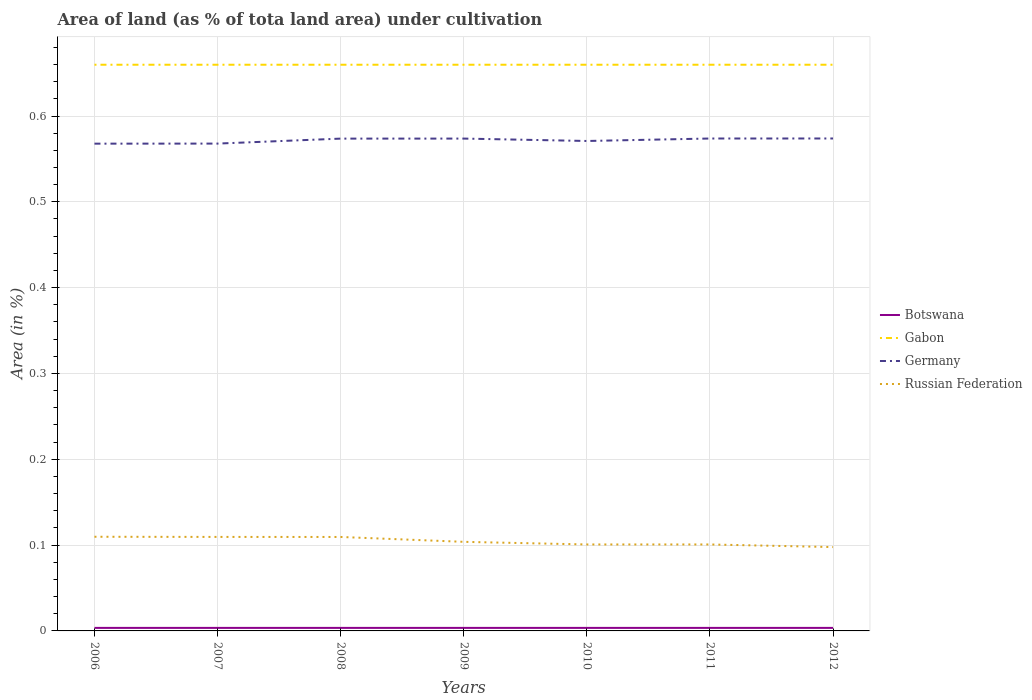How many different coloured lines are there?
Make the answer very short. 4. Does the line corresponding to Botswana intersect with the line corresponding to Gabon?
Offer a very short reply. No. Across all years, what is the maximum percentage of land under cultivation in Gabon?
Offer a terse response. 0.66. In which year was the percentage of land under cultivation in Gabon maximum?
Your answer should be very brief. 2006. What is the total percentage of land under cultivation in Germany in the graph?
Provide a short and direct response. -0.01. What is the difference between the highest and the second highest percentage of land under cultivation in Russian Federation?
Offer a very short reply. 0.01. What is the difference between the highest and the lowest percentage of land under cultivation in Russian Federation?
Ensure brevity in your answer.  3. Is the percentage of land under cultivation in Russian Federation strictly greater than the percentage of land under cultivation in Gabon over the years?
Your response must be concise. Yes. How many lines are there?
Your answer should be very brief. 4. How many years are there in the graph?
Ensure brevity in your answer.  7. Are the values on the major ticks of Y-axis written in scientific E-notation?
Your response must be concise. No. Does the graph contain any zero values?
Your response must be concise. No. Where does the legend appear in the graph?
Your answer should be compact. Center right. How are the legend labels stacked?
Your answer should be very brief. Vertical. What is the title of the graph?
Make the answer very short. Area of land (as % of tota land area) under cultivation. What is the label or title of the X-axis?
Your answer should be very brief. Years. What is the label or title of the Y-axis?
Your answer should be compact. Area (in %). What is the Area (in %) in Botswana in 2006?
Give a very brief answer. 0. What is the Area (in %) of Gabon in 2006?
Your response must be concise. 0.66. What is the Area (in %) in Germany in 2006?
Your response must be concise. 0.57. What is the Area (in %) of Russian Federation in 2006?
Your response must be concise. 0.11. What is the Area (in %) of Botswana in 2007?
Your response must be concise. 0. What is the Area (in %) in Gabon in 2007?
Your response must be concise. 0.66. What is the Area (in %) in Germany in 2007?
Keep it short and to the point. 0.57. What is the Area (in %) in Russian Federation in 2007?
Keep it short and to the point. 0.11. What is the Area (in %) in Botswana in 2008?
Provide a succinct answer. 0. What is the Area (in %) in Gabon in 2008?
Provide a succinct answer. 0.66. What is the Area (in %) in Germany in 2008?
Ensure brevity in your answer.  0.57. What is the Area (in %) of Russian Federation in 2008?
Your answer should be compact. 0.11. What is the Area (in %) in Botswana in 2009?
Offer a very short reply. 0. What is the Area (in %) of Gabon in 2009?
Your answer should be compact. 0.66. What is the Area (in %) in Germany in 2009?
Make the answer very short. 0.57. What is the Area (in %) of Russian Federation in 2009?
Your answer should be very brief. 0.1. What is the Area (in %) in Botswana in 2010?
Your response must be concise. 0. What is the Area (in %) of Gabon in 2010?
Make the answer very short. 0.66. What is the Area (in %) of Germany in 2010?
Your answer should be compact. 0.57. What is the Area (in %) of Russian Federation in 2010?
Offer a terse response. 0.1. What is the Area (in %) in Botswana in 2011?
Your answer should be very brief. 0. What is the Area (in %) in Gabon in 2011?
Keep it short and to the point. 0.66. What is the Area (in %) in Germany in 2011?
Ensure brevity in your answer.  0.57. What is the Area (in %) in Russian Federation in 2011?
Your response must be concise. 0.1. What is the Area (in %) in Botswana in 2012?
Your answer should be compact. 0. What is the Area (in %) of Gabon in 2012?
Provide a succinct answer. 0.66. What is the Area (in %) of Germany in 2012?
Provide a short and direct response. 0.57. What is the Area (in %) in Russian Federation in 2012?
Make the answer very short. 0.1. Across all years, what is the maximum Area (in %) in Botswana?
Provide a succinct answer. 0. Across all years, what is the maximum Area (in %) in Gabon?
Keep it short and to the point. 0.66. Across all years, what is the maximum Area (in %) of Germany?
Ensure brevity in your answer.  0.57. Across all years, what is the maximum Area (in %) in Russian Federation?
Ensure brevity in your answer.  0.11. Across all years, what is the minimum Area (in %) in Botswana?
Make the answer very short. 0. Across all years, what is the minimum Area (in %) of Gabon?
Offer a very short reply. 0.66. Across all years, what is the minimum Area (in %) of Germany?
Your response must be concise. 0.57. Across all years, what is the minimum Area (in %) in Russian Federation?
Your answer should be compact. 0.1. What is the total Area (in %) in Botswana in the graph?
Offer a very short reply. 0.02. What is the total Area (in %) of Gabon in the graph?
Provide a succinct answer. 4.62. What is the total Area (in %) in Germany in the graph?
Provide a short and direct response. 4. What is the total Area (in %) in Russian Federation in the graph?
Give a very brief answer. 0.73. What is the difference between the Area (in %) in Botswana in 2006 and that in 2007?
Keep it short and to the point. 0. What is the difference between the Area (in %) in Germany in 2006 and that in 2007?
Make the answer very short. -0. What is the difference between the Area (in %) in Botswana in 2006 and that in 2008?
Your answer should be compact. 0. What is the difference between the Area (in %) of Germany in 2006 and that in 2008?
Give a very brief answer. -0.01. What is the difference between the Area (in %) in Botswana in 2006 and that in 2009?
Ensure brevity in your answer.  0. What is the difference between the Area (in %) of Germany in 2006 and that in 2009?
Ensure brevity in your answer.  -0.01. What is the difference between the Area (in %) of Russian Federation in 2006 and that in 2009?
Provide a succinct answer. 0.01. What is the difference between the Area (in %) of Germany in 2006 and that in 2010?
Offer a terse response. -0. What is the difference between the Area (in %) in Russian Federation in 2006 and that in 2010?
Provide a succinct answer. 0.01. What is the difference between the Area (in %) of Germany in 2006 and that in 2011?
Your answer should be very brief. -0.01. What is the difference between the Area (in %) of Russian Federation in 2006 and that in 2011?
Give a very brief answer. 0.01. What is the difference between the Area (in %) of Germany in 2006 and that in 2012?
Provide a succinct answer. -0.01. What is the difference between the Area (in %) of Russian Federation in 2006 and that in 2012?
Give a very brief answer. 0.01. What is the difference between the Area (in %) in Germany in 2007 and that in 2008?
Keep it short and to the point. -0.01. What is the difference between the Area (in %) in Russian Federation in 2007 and that in 2008?
Your answer should be compact. 0. What is the difference between the Area (in %) in Botswana in 2007 and that in 2009?
Make the answer very short. 0. What is the difference between the Area (in %) in Gabon in 2007 and that in 2009?
Give a very brief answer. 0. What is the difference between the Area (in %) in Germany in 2007 and that in 2009?
Your answer should be very brief. -0.01. What is the difference between the Area (in %) of Russian Federation in 2007 and that in 2009?
Provide a short and direct response. 0.01. What is the difference between the Area (in %) of Germany in 2007 and that in 2010?
Your answer should be compact. -0. What is the difference between the Area (in %) of Russian Federation in 2007 and that in 2010?
Offer a terse response. 0.01. What is the difference between the Area (in %) of Germany in 2007 and that in 2011?
Keep it short and to the point. -0.01. What is the difference between the Area (in %) in Russian Federation in 2007 and that in 2011?
Make the answer very short. 0.01. What is the difference between the Area (in %) in Botswana in 2007 and that in 2012?
Ensure brevity in your answer.  0. What is the difference between the Area (in %) of Gabon in 2007 and that in 2012?
Provide a short and direct response. 0. What is the difference between the Area (in %) in Germany in 2007 and that in 2012?
Offer a very short reply. -0.01. What is the difference between the Area (in %) of Russian Federation in 2007 and that in 2012?
Offer a very short reply. 0.01. What is the difference between the Area (in %) of Botswana in 2008 and that in 2009?
Offer a very short reply. 0. What is the difference between the Area (in %) of Russian Federation in 2008 and that in 2009?
Your answer should be compact. 0.01. What is the difference between the Area (in %) in Gabon in 2008 and that in 2010?
Keep it short and to the point. 0. What is the difference between the Area (in %) of Germany in 2008 and that in 2010?
Offer a terse response. 0. What is the difference between the Area (in %) of Russian Federation in 2008 and that in 2010?
Provide a short and direct response. 0.01. What is the difference between the Area (in %) in Gabon in 2008 and that in 2011?
Your answer should be very brief. 0. What is the difference between the Area (in %) in Germany in 2008 and that in 2011?
Your answer should be compact. -0. What is the difference between the Area (in %) in Russian Federation in 2008 and that in 2011?
Offer a terse response. 0.01. What is the difference between the Area (in %) in Gabon in 2008 and that in 2012?
Give a very brief answer. 0. What is the difference between the Area (in %) of Germany in 2008 and that in 2012?
Your answer should be compact. -0. What is the difference between the Area (in %) of Russian Federation in 2008 and that in 2012?
Provide a succinct answer. 0.01. What is the difference between the Area (in %) of Botswana in 2009 and that in 2010?
Offer a terse response. 0. What is the difference between the Area (in %) of Germany in 2009 and that in 2010?
Keep it short and to the point. 0. What is the difference between the Area (in %) in Russian Federation in 2009 and that in 2010?
Provide a succinct answer. 0. What is the difference between the Area (in %) in Botswana in 2009 and that in 2011?
Ensure brevity in your answer.  0. What is the difference between the Area (in %) of Gabon in 2009 and that in 2011?
Ensure brevity in your answer.  0. What is the difference between the Area (in %) in Germany in 2009 and that in 2011?
Keep it short and to the point. -0. What is the difference between the Area (in %) of Russian Federation in 2009 and that in 2011?
Provide a short and direct response. 0. What is the difference between the Area (in %) in Botswana in 2009 and that in 2012?
Provide a succinct answer. 0. What is the difference between the Area (in %) of Gabon in 2009 and that in 2012?
Give a very brief answer. 0. What is the difference between the Area (in %) in Germany in 2009 and that in 2012?
Your answer should be very brief. -0. What is the difference between the Area (in %) of Russian Federation in 2009 and that in 2012?
Provide a succinct answer. 0.01. What is the difference between the Area (in %) in Gabon in 2010 and that in 2011?
Your answer should be compact. 0. What is the difference between the Area (in %) in Germany in 2010 and that in 2011?
Your answer should be compact. -0. What is the difference between the Area (in %) in Russian Federation in 2010 and that in 2011?
Ensure brevity in your answer.  0. What is the difference between the Area (in %) of Botswana in 2010 and that in 2012?
Provide a succinct answer. 0. What is the difference between the Area (in %) in Gabon in 2010 and that in 2012?
Keep it short and to the point. 0. What is the difference between the Area (in %) of Germany in 2010 and that in 2012?
Your response must be concise. -0. What is the difference between the Area (in %) of Russian Federation in 2010 and that in 2012?
Provide a short and direct response. 0. What is the difference between the Area (in %) in Russian Federation in 2011 and that in 2012?
Make the answer very short. 0. What is the difference between the Area (in %) of Botswana in 2006 and the Area (in %) of Gabon in 2007?
Your response must be concise. -0.66. What is the difference between the Area (in %) of Botswana in 2006 and the Area (in %) of Germany in 2007?
Give a very brief answer. -0.56. What is the difference between the Area (in %) of Botswana in 2006 and the Area (in %) of Russian Federation in 2007?
Keep it short and to the point. -0.11. What is the difference between the Area (in %) in Gabon in 2006 and the Area (in %) in Germany in 2007?
Ensure brevity in your answer.  0.09. What is the difference between the Area (in %) in Gabon in 2006 and the Area (in %) in Russian Federation in 2007?
Give a very brief answer. 0.55. What is the difference between the Area (in %) of Germany in 2006 and the Area (in %) of Russian Federation in 2007?
Give a very brief answer. 0.46. What is the difference between the Area (in %) of Botswana in 2006 and the Area (in %) of Gabon in 2008?
Your answer should be very brief. -0.66. What is the difference between the Area (in %) of Botswana in 2006 and the Area (in %) of Germany in 2008?
Provide a short and direct response. -0.57. What is the difference between the Area (in %) of Botswana in 2006 and the Area (in %) of Russian Federation in 2008?
Offer a very short reply. -0.11. What is the difference between the Area (in %) in Gabon in 2006 and the Area (in %) in Germany in 2008?
Offer a very short reply. 0.09. What is the difference between the Area (in %) of Gabon in 2006 and the Area (in %) of Russian Federation in 2008?
Offer a terse response. 0.55. What is the difference between the Area (in %) in Germany in 2006 and the Area (in %) in Russian Federation in 2008?
Ensure brevity in your answer.  0.46. What is the difference between the Area (in %) of Botswana in 2006 and the Area (in %) of Gabon in 2009?
Your answer should be compact. -0.66. What is the difference between the Area (in %) in Botswana in 2006 and the Area (in %) in Germany in 2009?
Ensure brevity in your answer.  -0.57. What is the difference between the Area (in %) of Botswana in 2006 and the Area (in %) of Russian Federation in 2009?
Provide a short and direct response. -0.1. What is the difference between the Area (in %) in Gabon in 2006 and the Area (in %) in Germany in 2009?
Your answer should be compact. 0.09. What is the difference between the Area (in %) in Gabon in 2006 and the Area (in %) in Russian Federation in 2009?
Your answer should be compact. 0.56. What is the difference between the Area (in %) of Germany in 2006 and the Area (in %) of Russian Federation in 2009?
Give a very brief answer. 0.46. What is the difference between the Area (in %) of Botswana in 2006 and the Area (in %) of Gabon in 2010?
Your answer should be very brief. -0.66. What is the difference between the Area (in %) of Botswana in 2006 and the Area (in %) of Germany in 2010?
Provide a succinct answer. -0.57. What is the difference between the Area (in %) in Botswana in 2006 and the Area (in %) in Russian Federation in 2010?
Your answer should be compact. -0.1. What is the difference between the Area (in %) of Gabon in 2006 and the Area (in %) of Germany in 2010?
Offer a very short reply. 0.09. What is the difference between the Area (in %) of Gabon in 2006 and the Area (in %) of Russian Federation in 2010?
Your answer should be compact. 0.56. What is the difference between the Area (in %) of Germany in 2006 and the Area (in %) of Russian Federation in 2010?
Keep it short and to the point. 0.47. What is the difference between the Area (in %) of Botswana in 2006 and the Area (in %) of Gabon in 2011?
Your answer should be very brief. -0.66. What is the difference between the Area (in %) in Botswana in 2006 and the Area (in %) in Germany in 2011?
Ensure brevity in your answer.  -0.57. What is the difference between the Area (in %) in Botswana in 2006 and the Area (in %) in Russian Federation in 2011?
Provide a short and direct response. -0.1. What is the difference between the Area (in %) of Gabon in 2006 and the Area (in %) of Germany in 2011?
Provide a succinct answer. 0.09. What is the difference between the Area (in %) in Gabon in 2006 and the Area (in %) in Russian Federation in 2011?
Ensure brevity in your answer.  0.56. What is the difference between the Area (in %) of Germany in 2006 and the Area (in %) of Russian Federation in 2011?
Your answer should be very brief. 0.47. What is the difference between the Area (in %) in Botswana in 2006 and the Area (in %) in Gabon in 2012?
Your response must be concise. -0.66. What is the difference between the Area (in %) of Botswana in 2006 and the Area (in %) of Germany in 2012?
Your response must be concise. -0.57. What is the difference between the Area (in %) in Botswana in 2006 and the Area (in %) in Russian Federation in 2012?
Your response must be concise. -0.09. What is the difference between the Area (in %) in Gabon in 2006 and the Area (in %) in Germany in 2012?
Provide a short and direct response. 0.09. What is the difference between the Area (in %) in Gabon in 2006 and the Area (in %) in Russian Federation in 2012?
Your response must be concise. 0.56. What is the difference between the Area (in %) of Germany in 2006 and the Area (in %) of Russian Federation in 2012?
Offer a terse response. 0.47. What is the difference between the Area (in %) of Botswana in 2007 and the Area (in %) of Gabon in 2008?
Your response must be concise. -0.66. What is the difference between the Area (in %) of Botswana in 2007 and the Area (in %) of Germany in 2008?
Your answer should be compact. -0.57. What is the difference between the Area (in %) in Botswana in 2007 and the Area (in %) in Russian Federation in 2008?
Give a very brief answer. -0.11. What is the difference between the Area (in %) in Gabon in 2007 and the Area (in %) in Germany in 2008?
Make the answer very short. 0.09. What is the difference between the Area (in %) in Gabon in 2007 and the Area (in %) in Russian Federation in 2008?
Your response must be concise. 0.55. What is the difference between the Area (in %) in Germany in 2007 and the Area (in %) in Russian Federation in 2008?
Provide a short and direct response. 0.46. What is the difference between the Area (in %) of Botswana in 2007 and the Area (in %) of Gabon in 2009?
Provide a short and direct response. -0.66. What is the difference between the Area (in %) in Botswana in 2007 and the Area (in %) in Germany in 2009?
Ensure brevity in your answer.  -0.57. What is the difference between the Area (in %) in Botswana in 2007 and the Area (in %) in Russian Federation in 2009?
Offer a very short reply. -0.1. What is the difference between the Area (in %) in Gabon in 2007 and the Area (in %) in Germany in 2009?
Offer a very short reply. 0.09. What is the difference between the Area (in %) in Gabon in 2007 and the Area (in %) in Russian Federation in 2009?
Provide a succinct answer. 0.56. What is the difference between the Area (in %) of Germany in 2007 and the Area (in %) of Russian Federation in 2009?
Give a very brief answer. 0.46. What is the difference between the Area (in %) of Botswana in 2007 and the Area (in %) of Gabon in 2010?
Offer a terse response. -0.66. What is the difference between the Area (in %) in Botswana in 2007 and the Area (in %) in Germany in 2010?
Ensure brevity in your answer.  -0.57. What is the difference between the Area (in %) in Botswana in 2007 and the Area (in %) in Russian Federation in 2010?
Offer a very short reply. -0.1. What is the difference between the Area (in %) of Gabon in 2007 and the Area (in %) of Germany in 2010?
Give a very brief answer. 0.09. What is the difference between the Area (in %) in Gabon in 2007 and the Area (in %) in Russian Federation in 2010?
Offer a very short reply. 0.56. What is the difference between the Area (in %) in Germany in 2007 and the Area (in %) in Russian Federation in 2010?
Make the answer very short. 0.47. What is the difference between the Area (in %) in Botswana in 2007 and the Area (in %) in Gabon in 2011?
Ensure brevity in your answer.  -0.66. What is the difference between the Area (in %) of Botswana in 2007 and the Area (in %) of Germany in 2011?
Keep it short and to the point. -0.57. What is the difference between the Area (in %) of Botswana in 2007 and the Area (in %) of Russian Federation in 2011?
Your answer should be compact. -0.1. What is the difference between the Area (in %) in Gabon in 2007 and the Area (in %) in Germany in 2011?
Your answer should be very brief. 0.09. What is the difference between the Area (in %) of Gabon in 2007 and the Area (in %) of Russian Federation in 2011?
Offer a very short reply. 0.56. What is the difference between the Area (in %) in Germany in 2007 and the Area (in %) in Russian Federation in 2011?
Your answer should be compact. 0.47. What is the difference between the Area (in %) of Botswana in 2007 and the Area (in %) of Gabon in 2012?
Your answer should be compact. -0.66. What is the difference between the Area (in %) in Botswana in 2007 and the Area (in %) in Germany in 2012?
Keep it short and to the point. -0.57. What is the difference between the Area (in %) in Botswana in 2007 and the Area (in %) in Russian Federation in 2012?
Your answer should be very brief. -0.09. What is the difference between the Area (in %) of Gabon in 2007 and the Area (in %) of Germany in 2012?
Provide a succinct answer. 0.09. What is the difference between the Area (in %) of Gabon in 2007 and the Area (in %) of Russian Federation in 2012?
Offer a very short reply. 0.56. What is the difference between the Area (in %) in Germany in 2007 and the Area (in %) in Russian Federation in 2012?
Ensure brevity in your answer.  0.47. What is the difference between the Area (in %) of Botswana in 2008 and the Area (in %) of Gabon in 2009?
Make the answer very short. -0.66. What is the difference between the Area (in %) of Botswana in 2008 and the Area (in %) of Germany in 2009?
Keep it short and to the point. -0.57. What is the difference between the Area (in %) in Botswana in 2008 and the Area (in %) in Russian Federation in 2009?
Your answer should be compact. -0.1. What is the difference between the Area (in %) of Gabon in 2008 and the Area (in %) of Germany in 2009?
Make the answer very short. 0.09. What is the difference between the Area (in %) in Gabon in 2008 and the Area (in %) in Russian Federation in 2009?
Provide a succinct answer. 0.56. What is the difference between the Area (in %) of Germany in 2008 and the Area (in %) of Russian Federation in 2009?
Ensure brevity in your answer.  0.47. What is the difference between the Area (in %) of Botswana in 2008 and the Area (in %) of Gabon in 2010?
Your answer should be compact. -0.66. What is the difference between the Area (in %) of Botswana in 2008 and the Area (in %) of Germany in 2010?
Provide a succinct answer. -0.57. What is the difference between the Area (in %) of Botswana in 2008 and the Area (in %) of Russian Federation in 2010?
Give a very brief answer. -0.1. What is the difference between the Area (in %) in Gabon in 2008 and the Area (in %) in Germany in 2010?
Offer a terse response. 0.09. What is the difference between the Area (in %) in Gabon in 2008 and the Area (in %) in Russian Federation in 2010?
Give a very brief answer. 0.56. What is the difference between the Area (in %) of Germany in 2008 and the Area (in %) of Russian Federation in 2010?
Keep it short and to the point. 0.47. What is the difference between the Area (in %) of Botswana in 2008 and the Area (in %) of Gabon in 2011?
Keep it short and to the point. -0.66. What is the difference between the Area (in %) of Botswana in 2008 and the Area (in %) of Germany in 2011?
Give a very brief answer. -0.57. What is the difference between the Area (in %) of Botswana in 2008 and the Area (in %) of Russian Federation in 2011?
Keep it short and to the point. -0.1. What is the difference between the Area (in %) in Gabon in 2008 and the Area (in %) in Germany in 2011?
Provide a short and direct response. 0.09. What is the difference between the Area (in %) in Gabon in 2008 and the Area (in %) in Russian Federation in 2011?
Provide a short and direct response. 0.56. What is the difference between the Area (in %) in Germany in 2008 and the Area (in %) in Russian Federation in 2011?
Make the answer very short. 0.47. What is the difference between the Area (in %) in Botswana in 2008 and the Area (in %) in Gabon in 2012?
Your response must be concise. -0.66. What is the difference between the Area (in %) in Botswana in 2008 and the Area (in %) in Germany in 2012?
Ensure brevity in your answer.  -0.57. What is the difference between the Area (in %) of Botswana in 2008 and the Area (in %) of Russian Federation in 2012?
Offer a terse response. -0.09. What is the difference between the Area (in %) of Gabon in 2008 and the Area (in %) of Germany in 2012?
Your answer should be very brief. 0.09. What is the difference between the Area (in %) of Gabon in 2008 and the Area (in %) of Russian Federation in 2012?
Give a very brief answer. 0.56. What is the difference between the Area (in %) of Germany in 2008 and the Area (in %) of Russian Federation in 2012?
Offer a very short reply. 0.48. What is the difference between the Area (in %) in Botswana in 2009 and the Area (in %) in Gabon in 2010?
Your answer should be compact. -0.66. What is the difference between the Area (in %) in Botswana in 2009 and the Area (in %) in Germany in 2010?
Keep it short and to the point. -0.57. What is the difference between the Area (in %) in Botswana in 2009 and the Area (in %) in Russian Federation in 2010?
Offer a terse response. -0.1. What is the difference between the Area (in %) of Gabon in 2009 and the Area (in %) of Germany in 2010?
Provide a succinct answer. 0.09. What is the difference between the Area (in %) of Gabon in 2009 and the Area (in %) of Russian Federation in 2010?
Your response must be concise. 0.56. What is the difference between the Area (in %) in Germany in 2009 and the Area (in %) in Russian Federation in 2010?
Make the answer very short. 0.47. What is the difference between the Area (in %) of Botswana in 2009 and the Area (in %) of Gabon in 2011?
Ensure brevity in your answer.  -0.66. What is the difference between the Area (in %) of Botswana in 2009 and the Area (in %) of Germany in 2011?
Keep it short and to the point. -0.57. What is the difference between the Area (in %) of Botswana in 2009 and the Area (in %) of Russian Federation in 2011?
Provide a short and direct response. -0.1. What is the difference between the Area (in %) in Gabon in 2009 and the Area (in %) in Germany in 2011?
Your response must be concise. 0.09. What is the difference between the Area (in %) in Gabon in 2009 and the Area (in %) in Russian Federation in 2011?
Make the answer very short. 0.56. What is the difference between the Area (in %) in Germany in 2009 and the Area (in %) in Russian Federation in 2011?
Your answer should be very brief. 0.47. What is the difference between the Area (in %) in Botswana in 2009 and the Area (in %) in Gabon in 2012?
Ensure brevity in your answer.  -0.66. What is the difference between the Area (in %) in Botswana in 2009 and the Area (in %) in Germany in 2012?
Offer a very short reply. -0.57. What is the difference between the Area (in %) in Botswana in 2009 and the Area (in %) in Russian Federation in 2012?
Make the answer very short. -0.09. What is the difference between the Area (in %) of Gabon in 2009 and the Area (in %) of Germany in 2012?
Give a very brief answer. 0.09. What is the difference between the Area (in %) in Gabon in 2009 and the Area (in %) in Russian Federation in 2012?
Ensure brevity in your answer.  0.56. What is the difference between the Area (in %) in Germany in 2009 and the Area (in %) in Russian Federation in 2012?
Provide a short and direct response. 0.48. What is the difference between the Area (in %) of Botswana in 2010 and the Area (in %) of Gabon in 2011?
Make the answer very short. -0.66. What is the difference between the Area (in %) in Botswana in 2010 and the Area (in %) in Germany in 2011?
Provide a succinct answer. -0.57. What is the difference between the Area (in %) in Botswana in 2010 and the Area (in %) in Russian Federation in 2011?
Ensure brevity in your answer.  -0.1. What is the difference between the Area (in %) in Gabon in 2010 and the Area (in %) in Germany in 2011?
Your answer should be very brief. 0.09. What is the difference between the Area (in %) in Gabon in 2010 and the Area (in %) in Russian Federation in 2011?
Give a very brief answer. 0.56. What is the difference between the Area (in %) in Germany in 2010 and the Area (in %) in Russian Federation in 2011?
Give a very brief answer. 0.47. What is the difference between the Area (in %) in Botswana in 2010 and the Area (in %) in Gabon in 2012?
Keep it short and to the point. -0.66. What is the difference between the Area (in %) of Botswana in 2010 and the Area (in %) of Germany in 2012?
Your response must be concise. -0.57. What is the difference between the Area (in %) of Botswana in 2010 and the Area (in %) of Russian Federation in 2012?
Make the answer very short. -0.09. What is the difference between the Area (in %) of Gabon in 2010 and the Area (in %) of Germany in 2012?
Give a very brief answer. 0.09. What is the difference between the Area (in %) of Gabon in 2010 and the Area (in %) of Russian Federation in 2012?
Keep it short and to the point. 0.56. What is the difference between the Area (in %) in Germany in 2010 and the Area (in %) in Russian Federation in 2012?
Keep it short and to the point. 0.47. What is the difference between the Area (in %) of Botswana in 2011 and the Area (in %) of Gabon in 2012?
Your response must be concise. -0.66. What is the difference between the Area (in %) in Botswana in 2011 and the Area (in %) in Germany in 2012?
Ensure brevity in your answer.  -0.57. What is the difference between the Area (in %) in Botswana in 2011 and the Area (in %) in Russian Federation in 2012?
Offer a terse response. -0.09. What is the difference between the Area (in %) of Gabon in 2011 and the Area (in %) of Germany in 2012?
Offer a very short reply. 0.09. What is the difference between the Area (in %) in Gabon in 2011 and the Area (in %) in Russian Federation in 2012?
Offer a terse response. 0.56. What is the difference between the Area (in %) of Germany in 2011 and the Area (in %) of Russian Federation in 2012?
Your response must be concise. 0.48. What is the average Area (in %) of Botswana per year?
Provide a short and direct response. 0. What is the average Area (in %) in Gabon per year?
Keep it short and to the point. 0.66. What is the average Area (in %) of Germany per year?
Offer a terse response. 0.57. What is the average Area (in %) of Russian Federation per year?
Offer a very short reply. 0.1. In the year 2006, what is the difference between the Area (in %) in Botswana and Area (in %) in Gabon?
Offer a very short reply. -0.66. In the year 2006, what is the difference between the Area (in %) in Botswana and Area (in %) in Germany?
Ensure brevity in your answer.  -0.56. In the year 2006, what is the difference between the Area (in %) of Botswana and Area (in %) of Russian Federation?
Offer a terse response. -0.11. In the year 2006, what is the difference between the Area (in %) in Gabon and Area (in %) in Germany?
Your answer should be compact. 0.09. In the year 2006, what is the difference between the Area (in %) in Gabon and Area (in %) in Russian Federation?
Make the answer very short. 0.55. In the year 2006, what is the difference between the Area (in %) of Germany and Area (in %) of Russian Federation?
Your answer should be very brief. 0.46. In the year 2007, what is the difference between the Area (in %) in Botswana and Area (in %) in Gabon?
Offer a terse response. -0.66. In the year 2007, what is the difference between the Area (in %) in Botswana and Area (in %) in Germany?
Keep it short and to the point. -0.56. In the year 2007, what is the difference between the Area (in %) in Botswana and Area (in %) in Russian Federation?
Offer a very short reply. -0.11. In the year 2007, what is the difference between the Area (in %) in Gabon and Area (in %) in Germany?
Your answer should be compact. 0.09. In the year 2007, what is the difference between the Area (in %) of Gabon and Area (in %) of Russian Federation?
Give a very brief answer. 0.55. In the year 2007, what is the difference between the Area (in %) in Germany and Area (in %) in Russian Federation?
Your answer should be compact. 0.46. In the year 2008, what is the difference between the Area (in %) in Botswana and Area (in %) in Gabon?
Make the answer very short. -0.66. In the year 2008, what is the difference between the Area (in %) in Botswana and Area (in %) in Germany?
Ensure brevity in your answer.  -0.57. In the year 2008, what is the difference between the Area (in %) in Botswana and Area (in %) in Russian Federation?
Provide a short and direct response. -0.11. In the year 2008, what is the difference between the Area (in %) of Gabon and Area (in %) of Germany?
Offer a very short reply. 0.09. In the year 2008, what is the difference between the Area (in %) in Gabon and Area (in %) in Russian Federation?
Provide a short and direct response. 0.55. In the year 2008, what is the difference between the Area (in %) in Germany and Area (in %) in Russian Federation?
Ensure brevity in your answer.  0.46. In the year 2009, what is the difference between the Area (in %) in Botswana and Area (in %) in Gabon?
Give a very brief answer. -0.66. In the year 2009, what is the difference between the Area (in %) in Botswana and Area (in %) in Germany?
Keep it short and to the point. -0.57. In the year 2009, what is the difference between the Area (in %) of Botswana and Area (in %) of Russian Federation?
Give a very brief answer. -0.1. In the year 2009, what is the difference between the Area (in %) of Gabon and Area (in %) of Germany?
Keep it short and to the point. 0.09. In the year 2009, what is the difference between the Area (in %) of Gabon and Area (in %) of Russian Federation?
Provide a succinct answer. 0.56. In the year 2009, what is the difference between the Area (in %) of Germany and Area (in %) of Russian Federation?
Provide a succinct answer. 0.47. In the year 2010, what is the difference between the Area (in %) of Botswana and Area (in %) of Gabon?
Ensure brevity in your answer.  -0.66. In the year 2010, what is the difference between the Area (in %) of Botswana and Area (in %) of Germany?
Your answer should be very brief. -0.57. In the year 2010, what is the difference between the Area (in %) of Botswana and Area (in %) of Russian Federation?
Your answer should be very brief. -0.1. In the year 2010, what is the difference between the Area (in %) of Gabon and Area (in %) of Germany?
Your answer should be compact. 0.09. In the year 2010, what is the difference between the Area (in %) in Gabon and Area (in %) in Russian Federation?
Your answer should be compact. 0.56. In the year 2010, what is the difference between the Area (in %) of Germany and Area (in %) of Russian Federation?
Provide a short and direct response. 0.47. In the year 2011, what is the difference between the Area (in %) of Botswana and Area (in %) of Gabon?
Keep it short and to the point. -0.66. In the year 2011, what is the difference between the Area (in %) of Botswana and Area (in %) of Germany?
Your answer should be compact. -0.57. In the year 2011, what is the difference between the Area (in %) of Botswana and Area (in %) of Russian Federation?
Keep it short and to the point. -0.1. In the year 2011, what is the difference between the Area (in %) in Gabon and Area (in %) in Germany?
Your answer should be compact. 0.09. In the year 2011, what is the difference between the Area (in %) of Gabon and Area (in %) of Russian Federation?
Provide a short and direct response. 0.56. In the year 2011, what is the difference between the Area (in %) in Germany and Area (in %) in Russian Federation?
Provide a short and direct response. 0.47. In the year 2012, what is the difference between the Area (in %) in Botswana and Area (in %) in Gabon?
Make the answer very short. -0.66. In the year 2012, what is the difference between the Area (in %) in Botswana and Area (in %) in Germany?
Keep it short and to the point. -0.57. In the year 2012, what is the difference between the Area (in %) of Botswana and Area (in %) of Russian Federation?
Your response must be concise. -0.09. In the year 2012, what is the difference between the Area (in %) in Gabon and Area (in %) in Germany?
Provide a succinct answer. 0.09. In the year 2012, what is the difference between the Area (in %) in Gabon and Area (in %) in Russian Federation?
Keep it short and to the point. 0.56. In the year 2012, what is the difference between the Area (in %) of Germany and Area (in %) of Russian Federation?
Your answer should be very brief. 0.48. What is the ratio of the Area (in %) of Botswana in 2006 to that in 2007?
Provide a short and direct response. 1. What is the ratio of the Area (in %) of Germany in 2006 to that in 2007?
Your answer should be very brief. 1. What is the ratio of the Area (in %) of Russian Federation in 2006 to that in 2007?
Ensure brevity in your answer.  1. What is the ratio of the Area (in %) of Germany in 2006 to that in 2008?
Your response must be concise. 0.99. What is the ratio of the Area (in %) of Botswana in 2006 to that in 2009?
Give a very brief answer. 1. What is the ratio of the Area (in %) of Germany in 2006 to that in 2009?
Offer a terse response. 0.99. What is the ratio of the Area (in %) in Russian Federation in 2006 to that in 2009?
Make the answer very short. 1.06. What is the ratio of the Area (in %) of Botswana in 2006 to that in 2010?
Provide a succinct answer. 1. What is the ratio of the Area (in %) in Russian Federation in 2006 to that in 2010?
Make the answer very short. 1.09. What is the ratio of the Area (in %) of Botswana in 2006 to that in 2011?
Your answer should be compact. 1. What is the ratio of the Area (in %) in Gabon in 2006 to that in 2011?
Provide a short and direct response. 1. What is the ratio of the Area (in %) in Russian Federation in 2006 to that in 2011?
Provide a short and direct response. 1.09. What is the ratio of the Area (in %) of Russian Federation in 2006 to that in 2012?
Give a very brief answer. 1.12. What is the ratio of the Area (in %) in Botswana in 2007 to that in 2008?
Offer a very short reply. 1. What is the ratio of the Area (in %) in Gabon in 2007 to that in 2008?
Your answer should be very brief. 1. What is the ratio of the Area (in %) in Botswana in 2007 to that in 2009?
Keep it short and to the point. 1. What is the ratio of the Area (in %) of Gabon in 2007 to that in 2009?
Offer a terse response. 1. What is the ratio of the Area (in %) in Germany in 2007 to that in 2009?
Provide a succinct answer. 0.99. What is the ratio of the Area (in %) of Russian Federation in 2007 to that in 2009?
Your answer should be compact. 1.06. What is the ratio of the Area (in %) in Botswana in 2007 to that in 2010?
Your answer should be compact. 1. What is the ratio of the Area (in %) in Germany in 2007 to that in 2010?
Your answer should be very brief. 0.99. What is the ratio of the Area (in %) of Russian Federation in 2007 to that in 2010?
Your answer should be very brief. 1.09. What is the ratio of the Area (in %) of Botswana in 2007 to that in 2011?
Provide a succinct answer. 1. What is the ratio of the Area (in %) in Russian Federation in 2007 to that in 2011?
Your answer should be very brief. 1.09. What is the ratio of the Area (in %) in Russian Federation in 2007 to that in 2012?
Your answer should be very brief. 1.12. What is the ratio of the Area (in %) of Botswana in 2008 to that in 2009?
Make the answer very short. 1. What is the ratio of the Area (in %) in Gabon in 2008 to that in 2009?
Offer a very short reply. 1. What is the ratio of the Area (in %) of Russian Federation in 2008 to that in 2009?
Offer a terse response. 1.05. What is the ratio of the Area (in %) in Botswana in 2008 to that in 2010?
Provide a succinct answer. 1. What is the ratio of the Area (in %) in Russian Federation in 2008 to that in 2010?
Your response must be concise. 1.09. What is the ratio of the Area (in %) of Russian Federation in 2008 to that in 2011?
Give a very brief answer. 1.09. What is the ratio of the Area (in %) of Botswana in 2008 to that in 2012?
Your response must be concise. 1. What is the ratio of the Area (in %) of Russian Federation in 2008 to that in 2012?
Offer a very short reply. 1.12. What is the ratio of the Area (in %) in Gabon in 2009 to that in 2010?
Give a very brief answer. 1. What is the ratio of the Area (in %) in Russian Federation in 2009 to that in 2010?
Your answer should be very brief. 1.03. What is the ratio of the Area (in %) of Botswana in 2009 to that in 2011?
Make the answer very short. 1. What is the ratio of the Area (in %) of Germany in 2009 to that in 2011?
Provide a succinct answer. 1. What is the ratio of the Area (in %) in Russian Federation in 2009 to that in 2011?
Keep it short and to the point. 1.03. What is the ratio of the Area (in %) in Botswana in 2009 to that in 2012?
Keep it short and to the point. 1. What is the ratio of the Area (in %) of Gabon in 2009 to that in 2012?
Make the answer very short. 1. What is the ratio of the Area (in %) in Russian Federation in 2009 to that in 2012?
Provide a succinct answer. 1.06. What is the ratio of the Area (in %) of Germany in 2010 to that in 2011?
Make the answer very short. 0.99. What is the ratio of the Area (in %) in Russian Federation in 2010 to that in 2011?
Ensure brevity in your answer.  1. What is the ratio of the Area (in %) in Germany in 2010 to that in 2012?
Your response must be concise. 0.99. What is the ratio of the Area (in %) of Russian Federation in 2010 to that in 2012?
Ensure brevity in your answer.  1.03. What is the ratio of the Area (in %) of Gabon in 2011 to that in 2012?
Provide a succinct answer. 1. What is the ratio of the Area (in %) of Russian Federation in 2011 to that in 2012?
Offer a terse response. 1.03. What is the difference between the highest and the second highest Area (in %) in Gabon?
Your response must be concise. 0. What is the difference between the highest and the second highest Area (in %) in Russian Federation?
Keep it short and to the point. 0. What is the difference between the highest and the lowest Area (in %) in Gabon?
Keep it short and to the point. 0. What is the difference between the highest and the lowest Area (in %) in Germany?
Your answer should be compact. 0.01. What is the difference between the highest and the lowest Area (in %) of Russian Federation?
Provide a short and direct response. 0.01. 